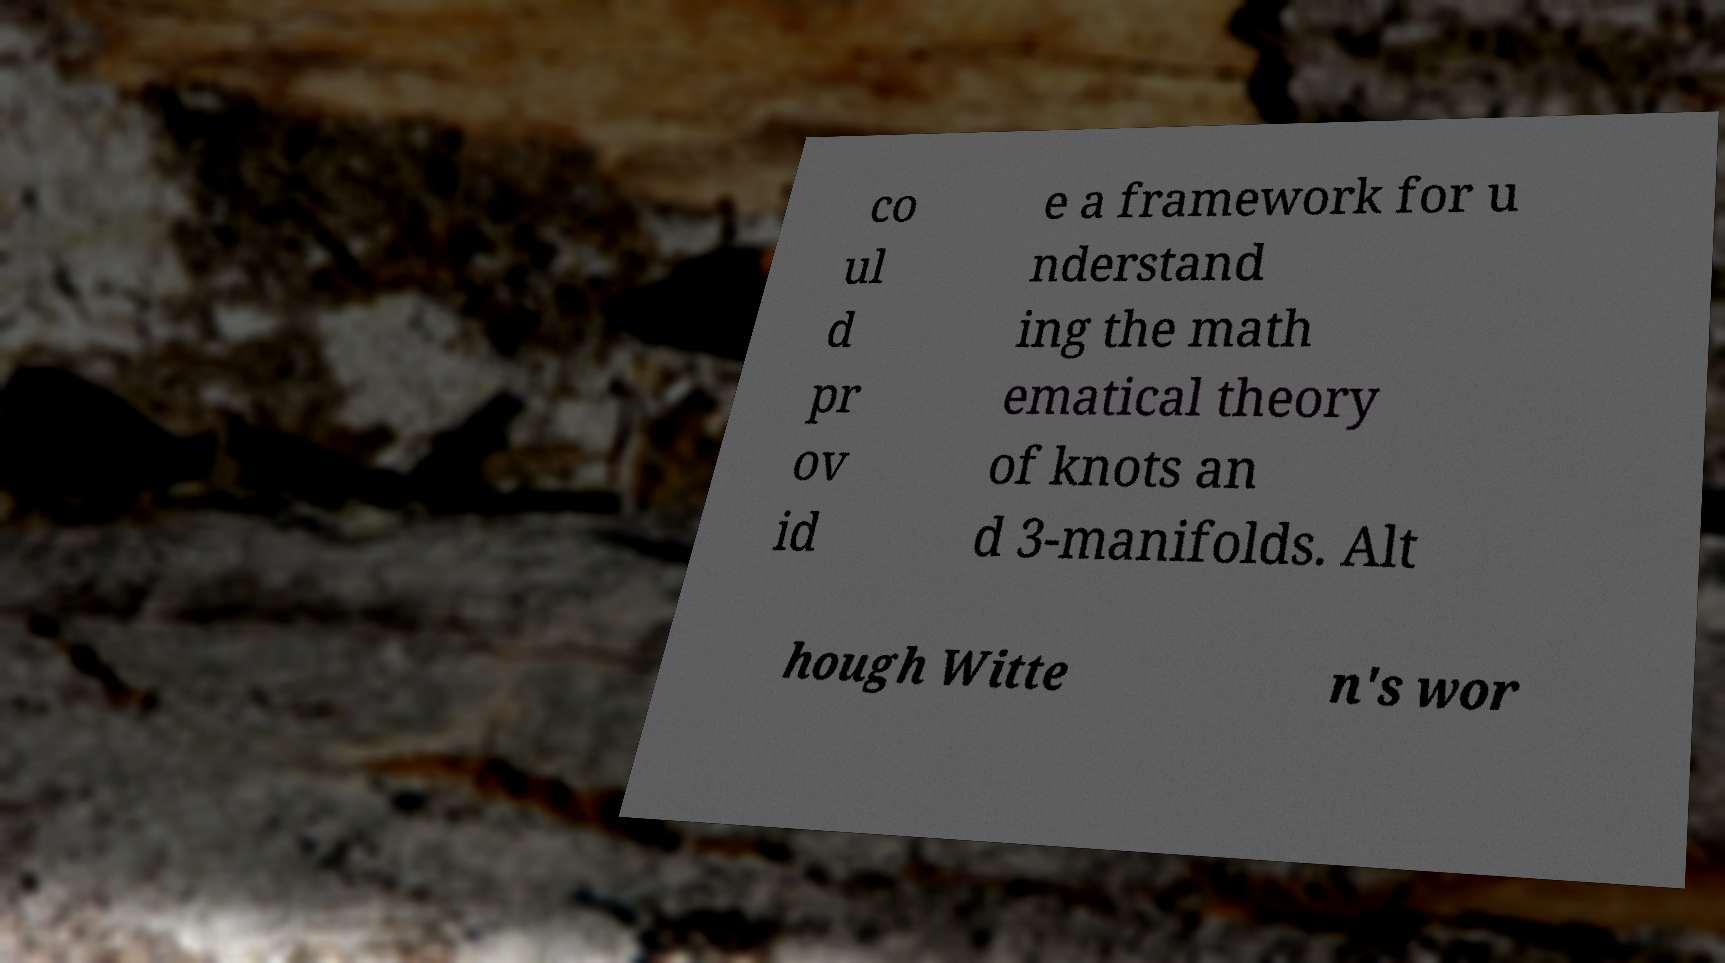There's text embedded in this image that I need extracted. Can you transcribe it verbatim? co ul d pr ov id e a framework for u nderstand ing the math ematical theory of knots an d 3-manifolds. Alt hough Witte n's wor 